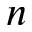<formula> <loc_0><loc_0><loc_500><loc_500>n</formula> 